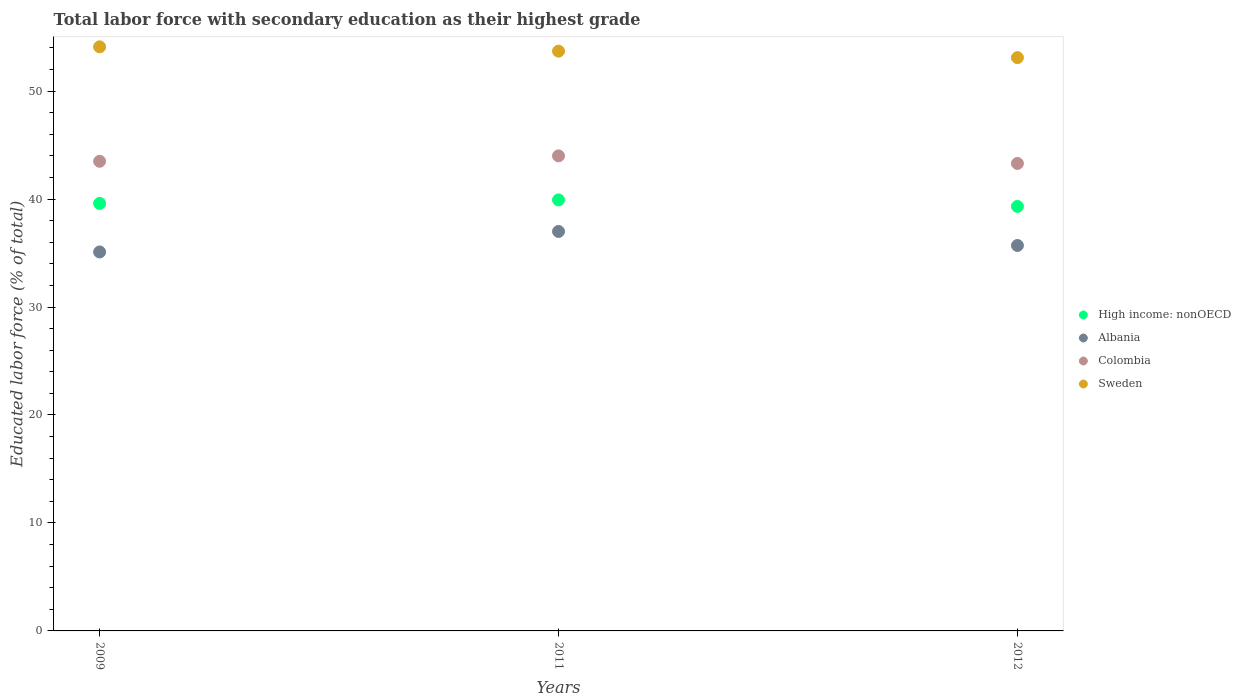Across all years, what is the maximum percentage of total labor force with primary education in Sweden?
Offer a terse response. 54.1. Across all years, what is the minimum percentage of total labor force with primary education in Albania?
Your answer should be very brief. 35.1. In which year was the percentage of total labor force with primary education in Sweden minimum?
Keep it short and to the point. 2012. What is the total percentage of total labor force with primary education in Sweden in the graph?
Make the answer very short. 160.9. What is the difference between the percentage of total labor force with primary education in Sweden in 2011 and that in 2012?
Offer a very short reply. 0.6. What is the difference between the percentage of total labor force with primary education in High income: nonOECD in 2011 and the percentage of total labor force with primary education in Colombia in 2012?
Your answer should be very brief. -3.38. What is the average percentage of total labor force with primary education in Sweden per year?
Provide a succinct answer. 53.63. In the year 2012, what is the difference between the percentage of total labor force with primary education in Albania and percentage of total labor force with primary education in Colombia?
Your answer should be very brief. -7.6. In how many years, is the percentage of total labor force with primary education in Albania greater than 28 %?
Your answer should be compact. 3. What is the ratio of the percentage of total labor force with primary education in Sweden in 2009 to that in 2011?
Keep it short and to the point. 1.01. Is the difference between the percentage of total labor force with primary education in Albania in 2011 and 2012 greater than the difference between the percentage of total labor force with primary education in Colombia in 2011 and 2012?
Your response must be concise. Yes. What is the difference between the highest and the second highest percentage of total labor force with primary education in High income: nonOECD?
Give a very brief answer. 0.32. What is the difference between the highest and the lowest percentage of total labor force with primary education in High income: nonOECD?
Your response must be concise. 0.6. In how many years, is the percentage of total labor force with primary education in Albania greater than the average percentage of total labor force with primary education in Albania taken over all years?
Your answer should be compact. 1. Is the sum of the percentage of total labor force with primary education in Sweden in 2011 and 2012 greater than the maximum percentage of total labor force with primary education in Albania across all years?
Your answer should be compact. Yes. Is it the case that in every year, the sum of the percentage of total labor force with primary education in High income: nonOECD and percentage of total labor force with primary education in Colombia  is greater than the sum of percentage of total labor force with primary education in Sweden and percentage of total labor force with primary education in Albania?
Keep it short and to the point. No. Is it the case that in every year, the sum of the percentage of total labor force with primary education in Albania and percentage of total labor force with primary education in Colombia  is greater than the percentage of total labor force with primary education in Sweden?
Offer a very short reply. Yes. Does the percentage of total labor force with primary education in Colombia monotonically increase over the years?
Ensure brevity in your answer.  No. Is the percentage of total labor force with primary education in Sweden strictly greater than the percentage of total labor force with primary education in Colombia over the years?
Keep it short and to the point. Yes. Is the percentage of total labor force with primary education in Albania strictly less than the percentage of total labor force with primary education in Sweden over the years?
Your response must be concise. Yes. Are the values on the major ticks of Y-axis written in scientific E-notation?
Your response must be concise. No. How are the legend labels stacked?
Ensure brevity in your answer.  Vertical. What is the title of the graph?
Provide a succinct answer. Total labor force with secondary education as their highest grade. What is the label or title of the Y-axis?
Provide a succinct answer. Educated labor force (% of total). What is the Educated labor force (% of total) of High income: nonOECD in 2009?
Keep it short and to the point. 39.6. What is the Educated labor force (% of total) in Albania in 2009?
Offer a terse response. 35.1. What is the Educated labor force (% of total) in Colombia in 2009?
Ensure brevity in your answer.  43.5. What is the Educated labor force (% of total) of Sweden in 2009?
Provide a short and direct response. 54.1. What is the Educated labor force (% of total) of High income: nonOECD in 2011?
Ensure brevity in your answer.  39.92. What is the Educated labor force (% of total) in Albania in 2011?
Give a very brief answer. 37. What is the Educated labor force (% of total) of Colombia in 2011?
Provide a succinct answer. 44. What is the Educated labor force (% of total) of Sweden in 2011?
Your response must be concise. 53.7. What is the Educated labor force (% of total) in High income: nonOECD in 2012?
Offer a very short reply. 39.32. What is the Educated labor force (% of total) in Albania in 2012?
Offer a very short reply. 35.7. What is the Educated labor force (% of total) of Colombia in 2012?
Offer a very short reply. 43.3. What is the Educated labor force (% of total) of Sweden in 2012?
Provide a short and direct response. 53.1. Across all years, what is the maximum Educated labor force (% of total) in High income: nonOECD?
Ensure brevity in your answer.  39.92. Across all years, what is the maximum Educated labor force (% of total) of Sweden?
Keep it short and to the point. 54.1. Across all years, what is the minimum Educated labor force (% of total) in High income: nonOECD?
Your answer should be very brief. 39.32. Across all years, what is the minimum Educated labor force (% of total) in Albania?
Provide a short and direct response. 35.1. Across all years, what is the minimum Educated labor force (% of total) in Colombia?
Offer a terse response. 43.3. Across all years, what is the minimum Educated labor force (% of total) of Sweden?
Offer a very short reply. 53.1. What is the total Educated labor force (% of total) of High income: nonOECD in the graph?
Offer a terse response. 118.84. What is the total Educated labor force (% of total) of Albania in the graph?
Your answer should be compact. 107.8. What is the total Educated labor force (% of total) in Colombia in the graph?
Your answer should be compact. 130.8. What is the total Educated labor force (% of total) in Sweden in the graph?
Offer a terse response. 160.9. What is the difference between the Educated labor force (% of total) in High income: nonOECD in 2009 and that in 2011?
Your answer should be compact. -0.32. What is the difference between the Educated labor force (% of total) of Albania in 2009 and that in 2011?
Your answer should be compact. -1.9. What is the difference between the Educated labor force (% of total) in Colombia in 2009 and that in 2011?
Ensure brevity in your answer.  -0.5. What is the difference between the Educated labor force (% of total) in High income: nonOECD in 2009 and that in 2012?
Provide a succinct answer. 0.28. What is the difference between the Educated labor force (% of total) of Albania in 2009 and that in 2012?
Ensure brevity in your answer.  -0.6. What is the difference between the Educated labor force (% of total) in High income: nonOECD in 2011 and that in 2012?
Your answer should be compact. 0.6. What is the difference between the Educated labor force (% of total) in Colombia in 2011 and that in 2012?
Your response must be concise. 0.7. What is the difference between the Educated labor force (% of total) in Sweden in 2011 and that in 2012?
Ensure brevity in your answer.  0.6. What is the difference between the Educated labor force (% of total) in High income: nonOECD in 2009 and the Educated labor force (% of total) in Colombia in 2011?
Your response must be concise. -4.4. What is the difference between the Educated labor force (% of total) of High income: nonOECD in 2009 and the Educated labor force (% of total) of Sweden in 2011?
Give a very brief answer. -14.1. What is the difference between the Educated labor force (% of total) in Albania in 2009 and the Educated labor force (% of total) in Colombia in 2011?
Provide a short and direct response. -8.9. What is the difference between the Educated labor force (% of total) in Albania in 2009 and the Educated labor force (% of total) in Sweden in 2011?
Make the answer very short. -18.6. What is the difference between the Educated labor force (% of total) of Colombia in 2009 and the Educated labor force (% of total) of Sweden in 2011?
Make the answer very short. -10.2. What is the difference between the Educated labor force (% of total) in High income: nonOECD in 2009 and the Educated labor force (% of total) in Albania in 2012?
Keep it short and to the point. 3.9. What is the difference between the Educated labor force (% of total) of High income: nonOECD in 2009 and the Educated labor force (% of total) of Sweden in 2012?
Your answer should be compact. -13.5. What is the difference between the Educated labor force (% of total) of Albania in 2009 and the Educated labor force (% of total) of Colombia in 2012?
Offer a very short reply. -8.2. What is the difference between the Educated labor force (% of total) in High income: nonOECD in 2011 and the Educated labor force (% of total) in Albania in 2012?
Offer a very short reply. 4.22. What is the difference between the Educated labor force (% of total) of High income: nonOECD in 2011 and the Educated labor force (% of total) of Colombia in 2012?
Your response must be concise. -3.38. What is the difference between the Educated labor force (% of total) in High income: nonOECD in 2011 and the Educated labor force (% of total) in Sweden in 2012?
Offer a very short reply. -13.18. What is the difference between the Educated labor force (% of total) in Albania in 2011 and the Educated labor force (% of total) in Colombia in 2012?
Keep it short and to the point. -6.3. What is the difference between the Educated labor force (% of total) of Albania in 2011 and the Educated labor force (% of total) of Sweden in 2012?
Your response must be concise. -16.1. What is the difference between the Educated labor force (% of total) in Colombia in 2011 and the Educated labor force (% of total) in Sweden in 2012?
Offer a very short reply. -9.1. What is the average Educated labor force (% of total) in High income: nonOECD per year?
Keep it short and to the point. 39.61. What is the average Educated labor force (% of total) in Albania per year?
Keep it short and to the point. 35.93. What is the average Educated labor force (% of total) of Colombia per year?
Ensure brevity in your answer.  43.6. What is the average Educated labor force (% of total) in Sweden per year?
Provide a short and direct response. 53.63. In the year 2009, what is the difference between the Educated labor force (% of total) in High income: nonOECD and Educated labor force (% of total) in Albania?
Give a very brief answer. 4.5. In the year 2009, what is the difference between the Educated labor force (% of total) in High income: nonOECD and Educated labor force (% of total) in Sweden?
Ensure brevity in your answer.  -14.5. In the year 2009, what is the difference between the Educated labor force (% of total) in Colombia and Educated labor force (% of total) in Sweden?
Give a very brief answer. -10.6. In the year 2011, what is the difference between the Educated labor force (% of total) of High income: nonOECD and Educated labor force (% of total) of Albania?
Ensure brevity in your answer.  2.92. In the year 2011, what is the difference between the Educated labor force (% of total) in High income: nonOECD and Educated labor force (% of total) in Colombia?
Ensure brevity in your answer.  -4.08. In the year 2011, what is the difference between the Educated labor force (% of total) of High income: nonOECD and Educated labor force (% of total) of Sweden?
Provide a succinct answer. -13.78. In the year 2011, what is the difference between the Educated labor force (% of total) in Albania and Educated labor force (% of total) in Colombia?
Give a very brief answer. -7. In the year 2011, what is the difference between the Educated labor force (% of total) of Albania and Educated labor force (% of total) of Sweden?
Keep it short and to the point. -16.7. In the year 2011, what is the difference between the Educated labor force (% of total) in Colombia and Educated labor force (% of total) in Sweden?
Your answer should be compact. -9.7. In the year 2012, what is the difference between the Educated labor force (% of total) of High income: nonOECD and Educated labor force (% of total) of Albania?
Offer a terse response. 3.62. In the year 2012, what is the difference between the Educated labor force (% of total) in High income: nonOECD and Educated labor force (% of total) in Colombia?
Make the answer very short. -3.98. In the year 2012, what is the difference between the Educated labor force (% of total) of High income: nonOECD and Educated labor force (% of total) of Sweden?
Your answer should be very brief. -13.78. In the year 2012, what is the difference between the Educated labor force (% of total) of Albania and Educated labor force (% of total) of Sweden?
Your response must be concise. -17.4. What is the ratio of the Educated labor force (% of total) of Albania in 2009 to that in 2011?
Provide a short and direct response. 0.95. What is the ratio of the Educated labor force (% of total) of Sweden in 2009 to that in 2011?
Provide a succinct answer. 1.01. What is the ratio of the Educated labor force (% of total) of High income: nonOECD in 2009 to that in 2012?
Offer a terse response. 1.01. What is the ratio of the Educated labor force (% of total) of Albania in 2009 to that in 2012?
Give a very brief answer. 0.98. What is the ratio of the Educated labor force (% of total) in Colombia in 2009 to that in 2012?
Your answer should be very brief. 1. What is the ratio of the Educated labor force (% of total) in Sweden in 2009 to that in 2012?
Provide a succinct answer. 1.02. What is the ratio of the Educated labor force (% of total) of High income: nonOECD in 2011 to that in 2012?
Provide a succinct answer. 1.02. What is the ratio of the Educated labor force (% of total) of Albania in 2011 to that in 2012?
Ensure brevity in your answer.  1.04. What is the ratio of the Educated labor force (% of total) in Colombia in 2011 to that in 2012?
Your answer should be very brief. 1.02. What is the ratio of the Educated labor force (% of total) of Sweden in 2011 to that in 2012?
Offer a terse response. 1.01. What is the difference between the highest and the second highest Educated labor force (% of total) of High income: nonOECD?
Your answer should be compact. 0.32. What is the difference between the highest and the second highest Educated labor force (% of total) in Albania?
Your answer should be very brief. 1.3. What is the difference between the highest and the second highest Educated labor force (% of total) in Sweden?
Offer a terse response. 0.4. What is the difference between the highest and the lowest Educated labor force (% of total) in High income: nonOECD?
Offer a very short reply. 0.6. What is the difference between the highest and the lowest Educated labor force (% of total) of Sweden?
Your answer should be compact. 1. 